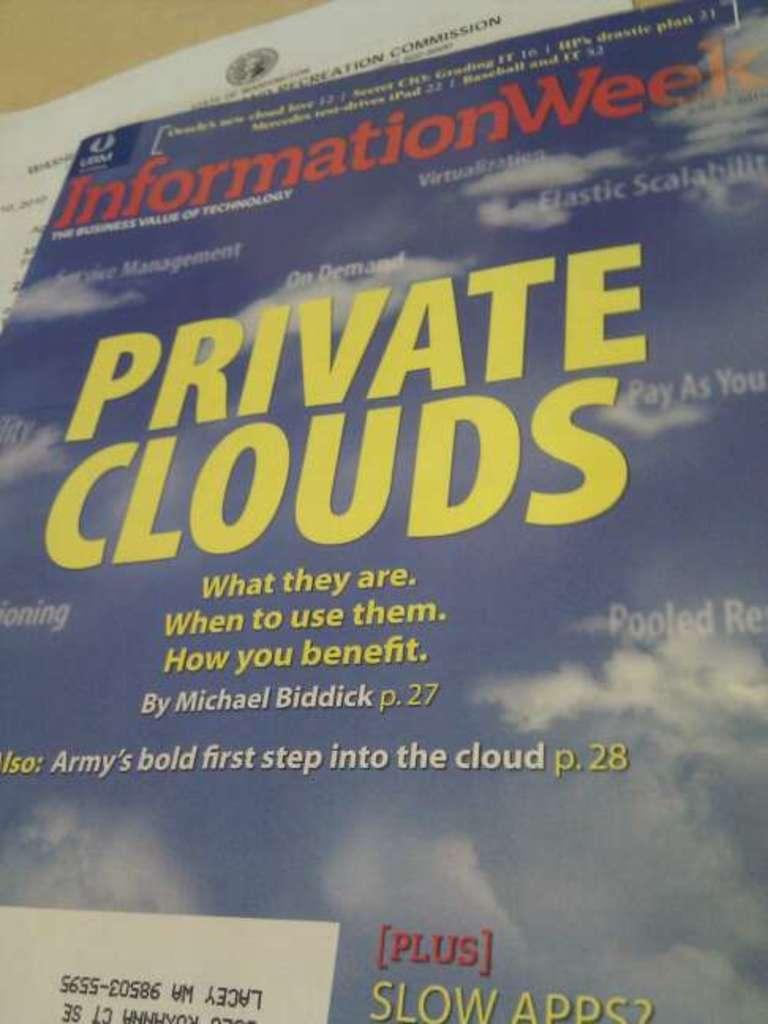<image>
Provide a brief description of the given image. An information poster with private clouds written on it 